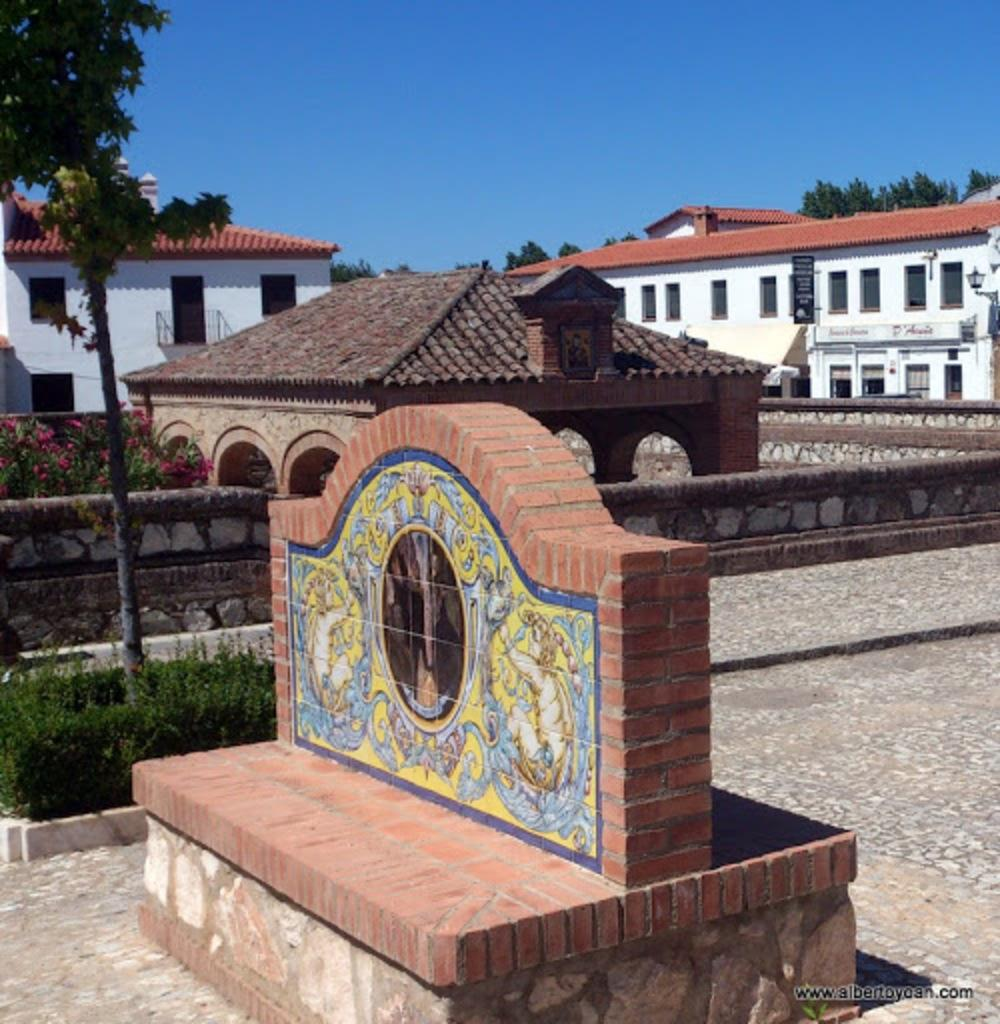What is located in the center of the picture? There are buildings, trees, plants, and flowers in the center of the picture. What can be seen in the foreground of the picture? There is a tree, plants, and a tombstone in the foreground of the picture. What is the condition of the sky in the picture? The sky is clear, and it is sunny in the picture. What type of collar is visible on the tombstone in the foreground of the picture? There is no collar present on the tombstone in the image. How does the wrench contribute to the expansion of the buildings in the center of the picture? There is no wrench present in the image, and the buildings are not expanding. 